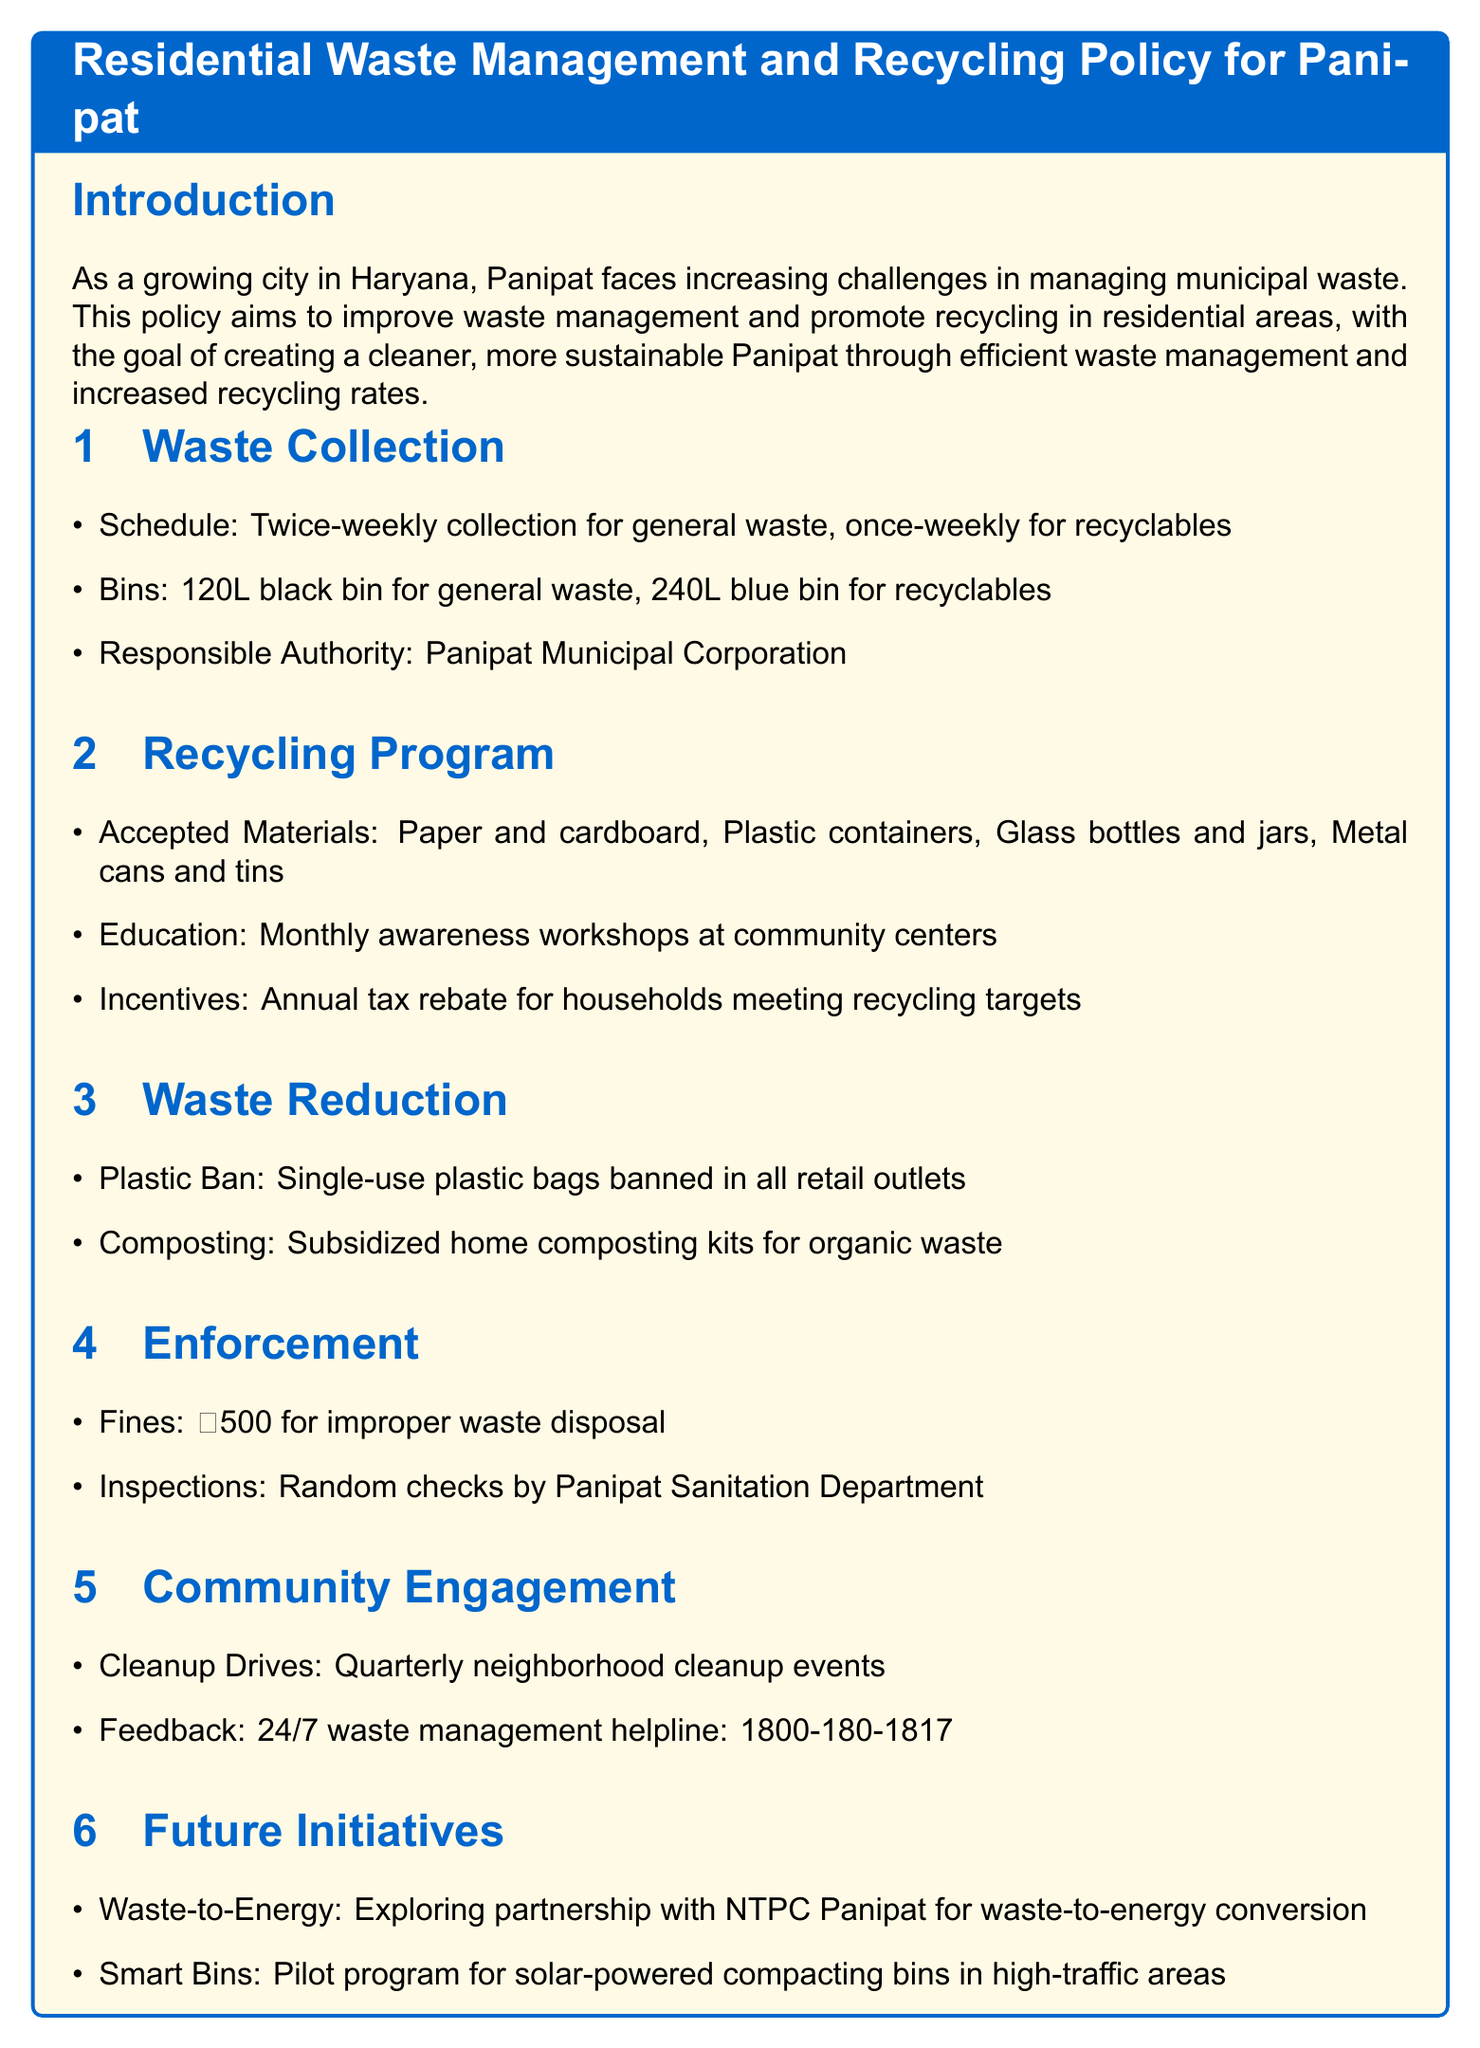What is the waste collection schedule for general waste? The document states that general waste is collected twice a week.
Answer: Twice-weekly Who is responsible for waste collection in Panipat? The document identifies the Panipat Municipal Corporation as the entity responsible for waste collection.
Answer: Panipat Municipal Corporation What is the fine for improper waste disposal? The document specifies that the fine for improper waste disposal is ₹500.
Answer: ₹500 How many materials are accepted in the recycling program? The document lists four accepted materials in the recycling program.
Answer: Four What type of event is organized quarterly to engage the community? The document mentions quarterly neighborhood cleanup events as a community engagement initiative.
Answer: Cleanup Drives What is the incentive for households meeting recycling targets? The document states that households meeting recycling targets receive an annual tax rebate as an incentive.
Answer: Annual tax rebate What is banned in all retail outlets according to the policy? The document indicates that single-use plastic bags are banned in all retail outlets.
Answer: Single-use plastic bags What type of waste reduction initiative provides subsidized kits? The document mentions subsidized home composting kits as part of the waste reduction initiative.
Answer: Composting What is being explored for future waste management initiatives? The document states that a partnership with NTPC Panipat for waste-to-energy conversion is being explored.
Answer: Waste-to-Energy 